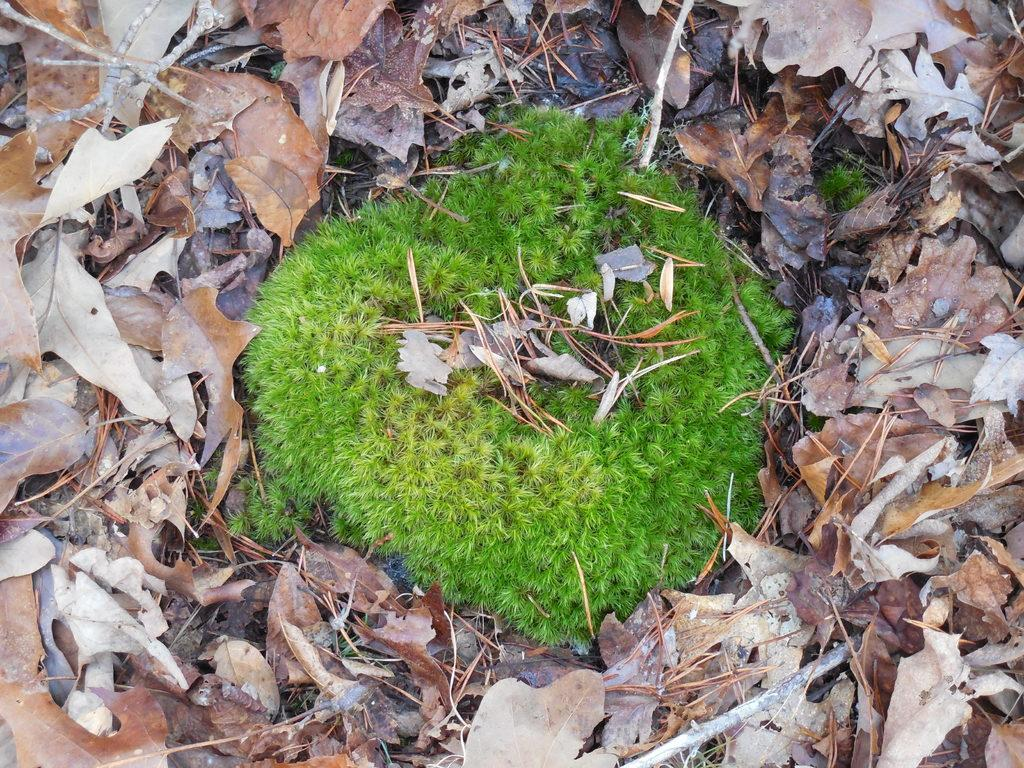What type of vegetation can be seen in the image? There is grass in the image. What else can be found on the ground in the image? There are dried leaves on the ground in the image. How does the mitten show respect in the image? There is no mitten present in the image, and therefore it cannot show respect or perform any actions. 